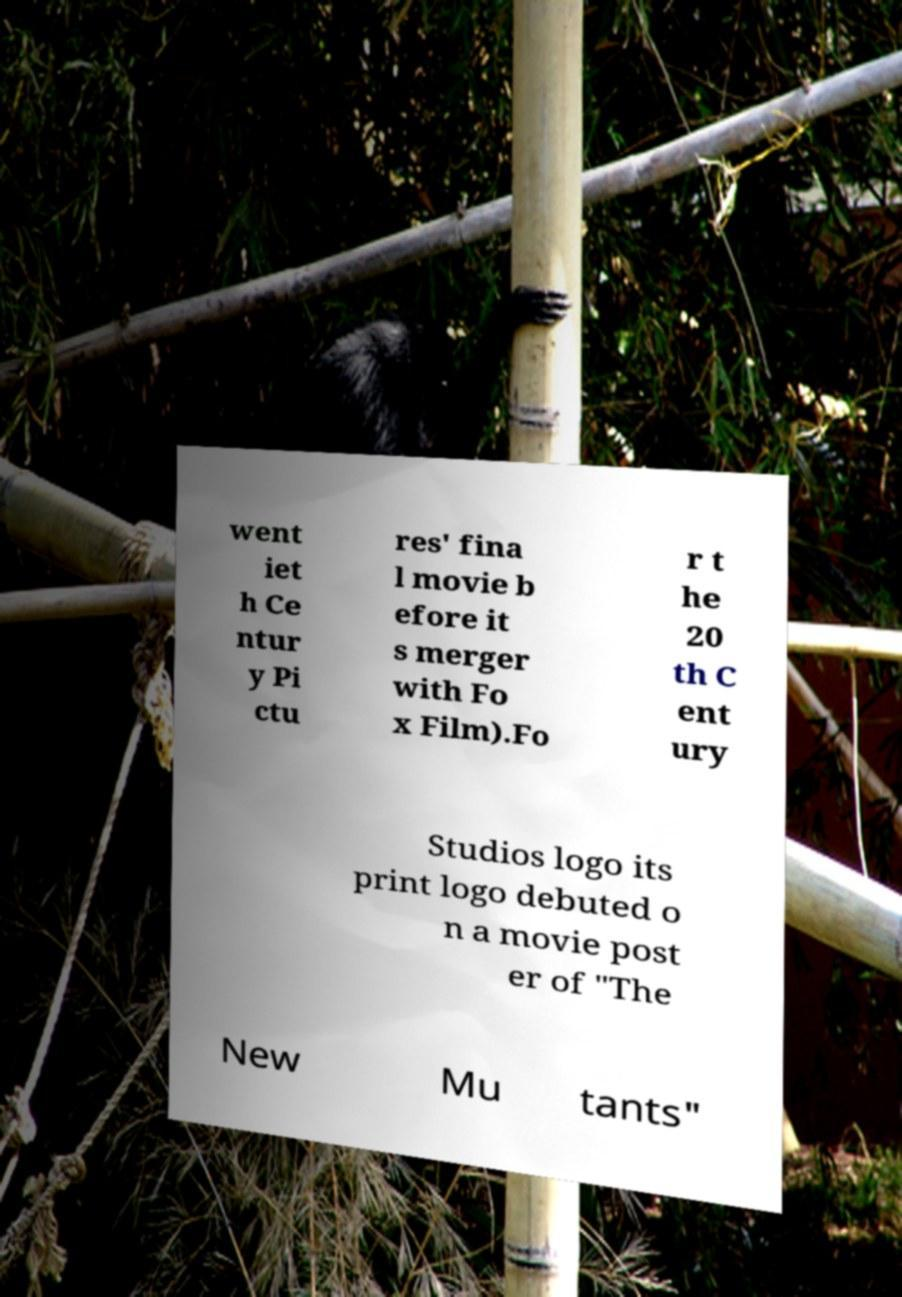Please identify and transcribe the text found in this image. went iet h Ce ntur y Pi ctu res' fina l movie b efore it s merger with Fo x Film).Fo r t he 20 th C ent ury Studios logo its print logo debuted o n a movie post er of "The New Mu tants" 